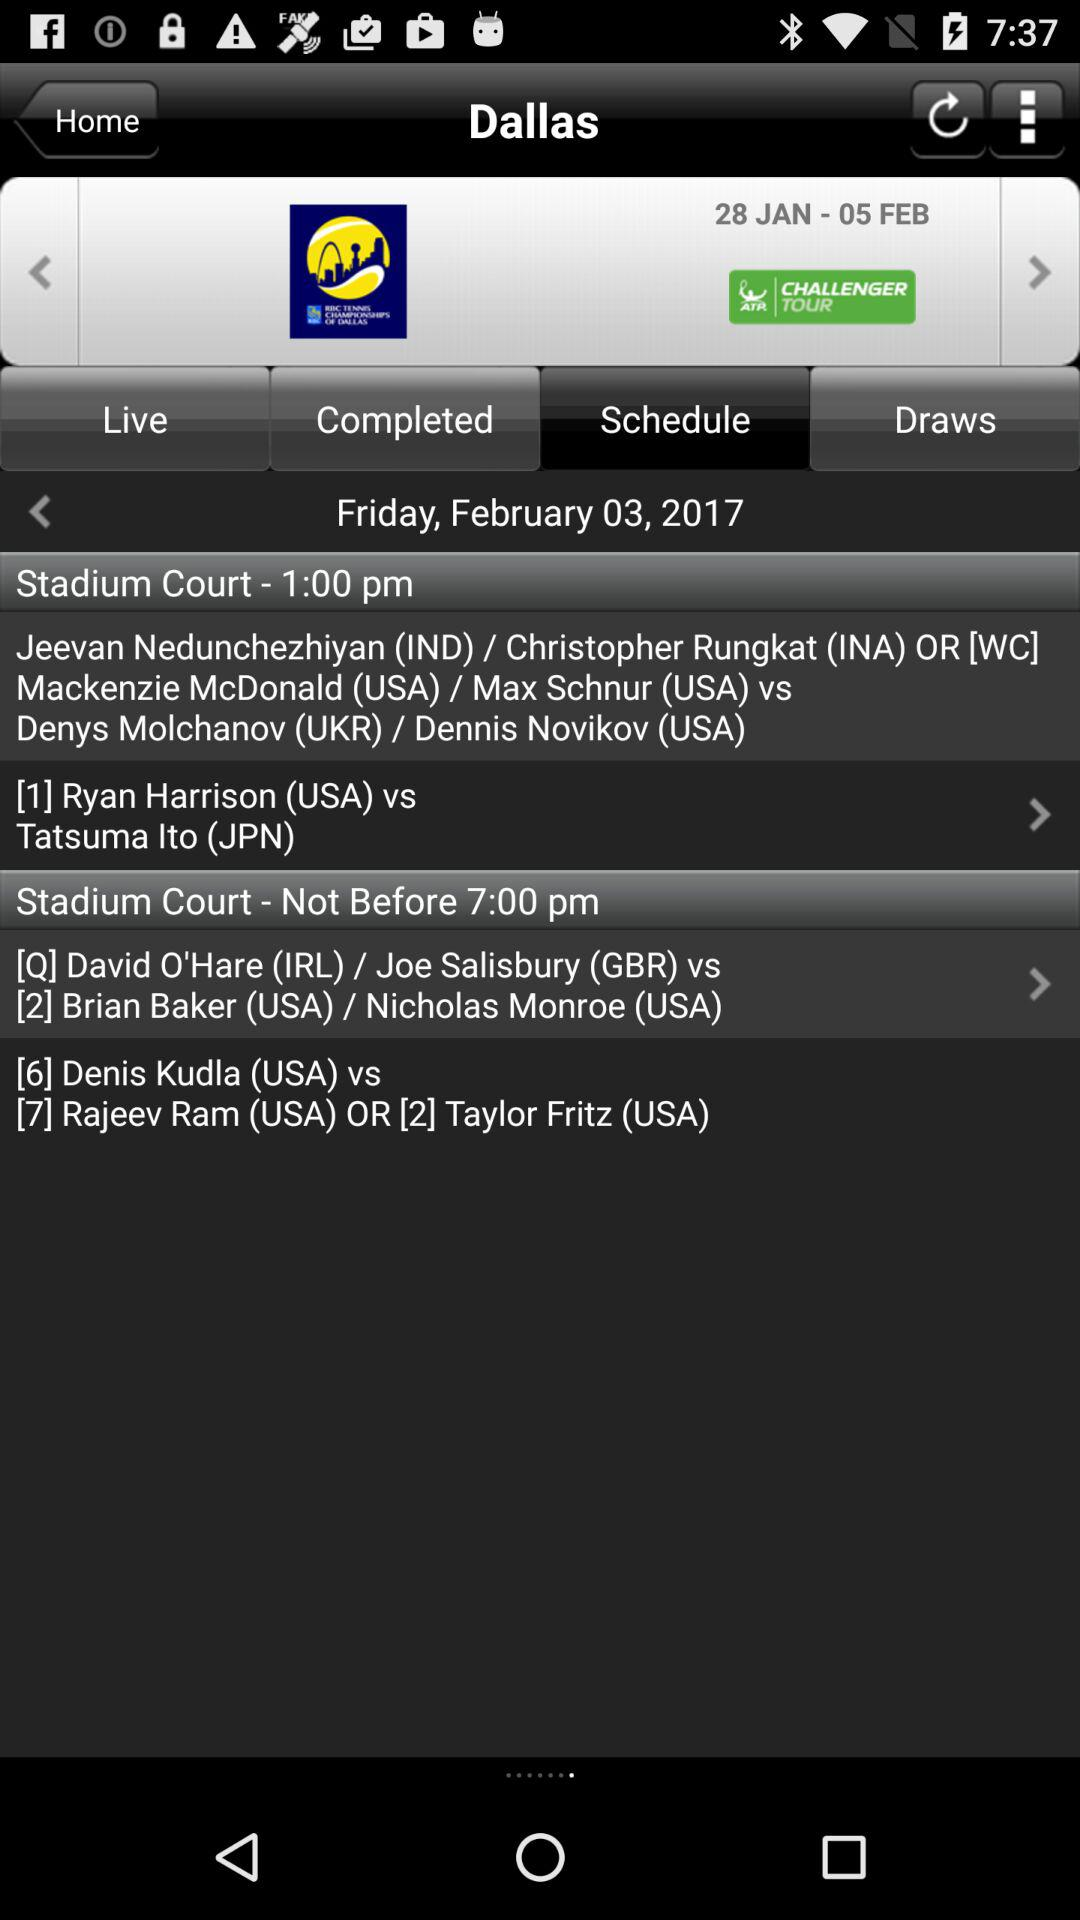What is the scheduled date of the tournament? The scheduled dates of the tournament are from January 28 to February 5. 